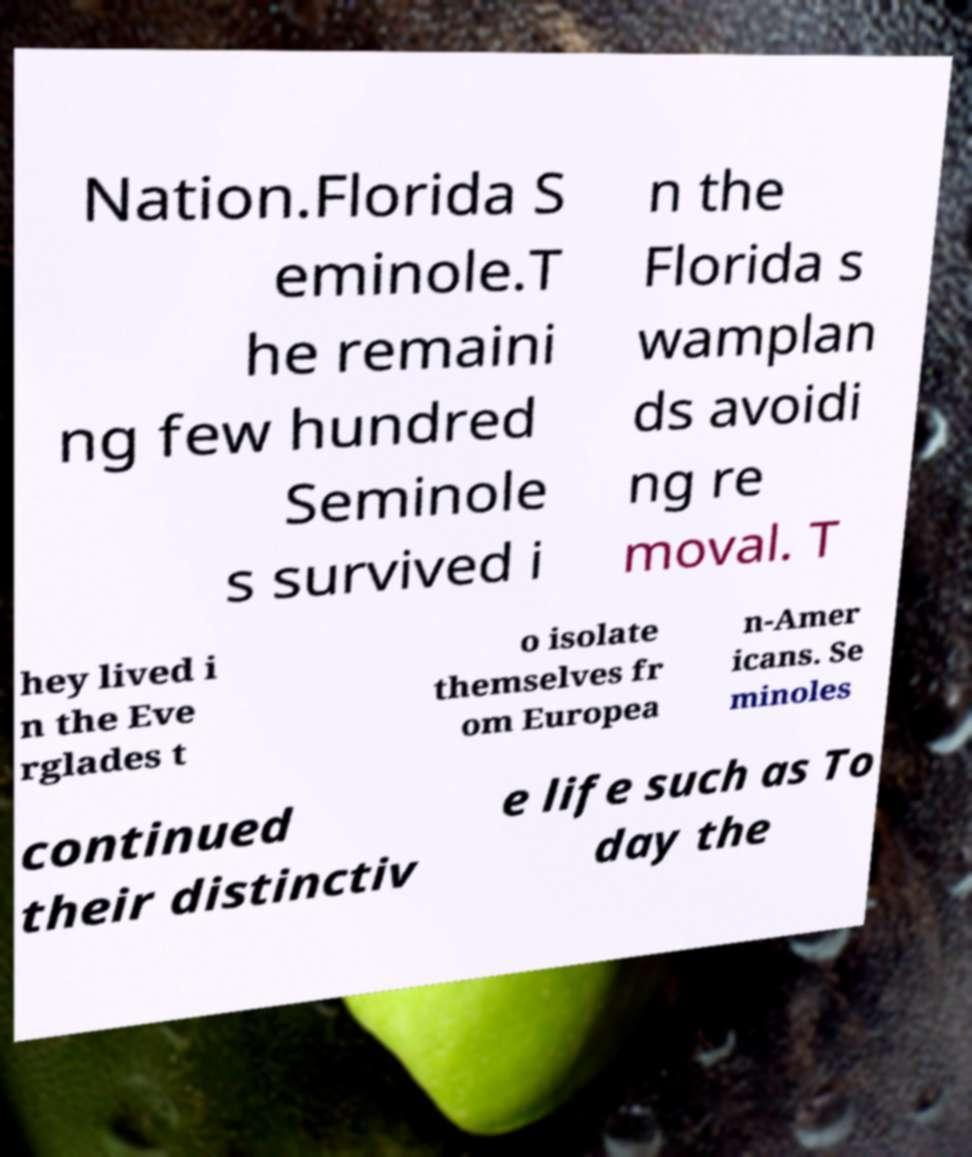Please identify and transcribe the text found in this image. Nation.Florida S eminole.T he remaini ng few hundred Seminole s survived i n the Florida s wamplan ds avoidi ng re moval. T hey lived i n the Eve rglades t o isolate themselves fr om Europea n-Amer icans. Se minoles continued their distinctiv e life such as To day the 